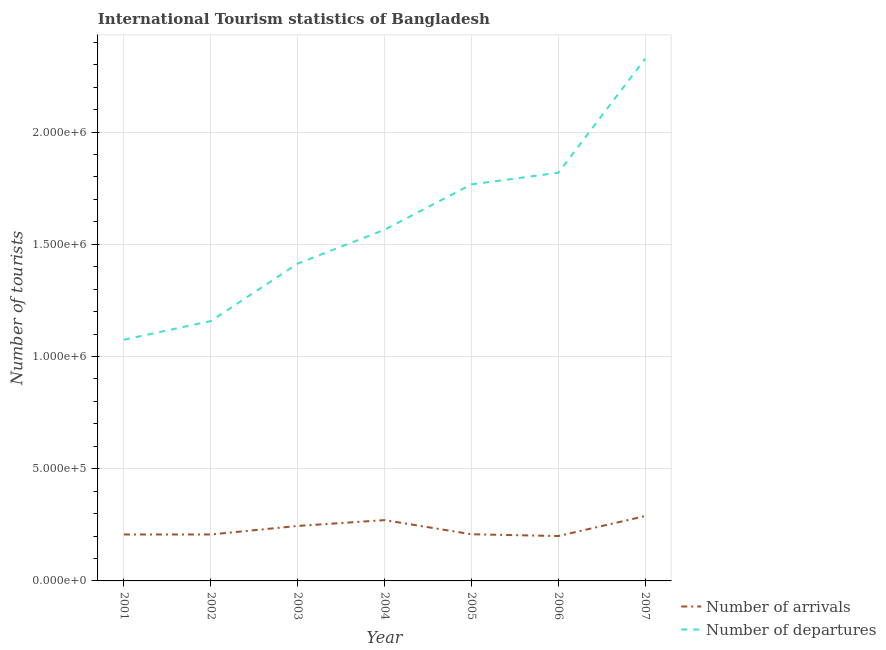Does the line corresponding to number of tourist departures intersect with the line corresponding to number of tourist arrivals?
Offer a terse response. No. What is the number of tourist arrivals in 2004?
Offer a terse response. 2.71e+05. Across all years, what is the maximum number of tourist departures?
Provide a short and direct response. 2.33e+06. Across all years, what is the minimum number of tourist arrivals?
Ensure brevity in your answer.  2.00e+05. In which year was the number of tourist departures maximum?
Your answer should be very brief. 2007. What is the total number of tourist arrivals in the graph?
Offer a very short reply. 1.63e+06. What is the difference between the number of tourist departures in 2001 and that in 2007?
Ensure brevity in your answer.  -1.25e+06. What is the difference between the number of tourist departures in 2004 and the number of tourist arrivals in 2001?
Offer a very short reply. 1.36e+06. What is the average number of tourist arrivals per year?
Offer a very short reply. 2.32e+05. In the year 2002, what is the difference between the number of tourist departures and number of tourist arrivals?
Ensure brevity in your answer.  9.51e+05. What is the ratio of the number of tourist departures in 2003 to that in 2004?
Your response must be concise. 0.9. Is the number of tourist arrivals in 2001 less than that in 2005?
Keep it short and to the point. Yes. Is the difference between the number of tourist arrivals in 2003 and 2005 greater than the difference between the number of tourist departures in 2003 and 2005?
Your answer should be very brief. Yes. What is the difference between the highest and the second highest number of tourist departures?
Give a very brief answer. 5.08e+05. What is the difference between the highest and the lowest number of tourist departures?
Your answer should be very brief. 1.25e+06. Is the number of tourist arrivals strictly greater than the number of tourist departures over the years?
Your answer should be very brief. No. What is the difference between two consecutive major ticks on the Y-axis?
Keep it short and to the point. 5.00e+05. Are the values on the major ticks of Y-axis written in scientific E-notation?
Your answer should be compact. Yes. Does the graph contain any zero values?
Offer a terse response. No. How many legend labels are there?
Keep it short and to the point. 2. What is the title of the graph?
Offer a terse response. International Tourism statistics of Bangladesh. What is the label or title of the Y-axis?
Your response must be concise. Number of tourists. What is the Number of tourists of Number of arrivals in 2001?
Ensure brevity in your answer.  2.07e+05. What is the Number of tourists in Number of departures in 2001?
Provide a short and direct response. 1.08e+06. What is the Number of tourists in Number of arrivals in 2002?
Keep it short and to the point. 2.07e+05. What is the Number of tourists of Number of departures in 2002?
Provide a succinct answer. 1.16e+06. What is the Number of tourists of Number of arrivals in 2003?
Provide a succinct answer. 2.45e+05. What is the Number of tourists of Number of departures in 2003?
Offer a very short reply. 1.41e+06. What is the Number of tourists in Number of arrivals in 2004?
Make the answer very short. 2.71e+05. What is the Number of tourists of Number of departures in 2004?
Your response must be concise. 1.56e+06. What is the Number of tourists in Number of arrivals in 2005?
Make the answer very short. 2.08e+05. What is the Number of tourists in Number of departures in 2005?
Provide a succinct answer. 1.77e+06. What is the Number of tourists in Number of departures in 2006?
Offer a very short reply. 1.82e+06. What is the Number of tourists of Number of arrivals in 2007?
Ensure brevity in your answer.  2.89e+05. What is the Number of tourists in Number of departures in 2007?
Your answer should be very brief. 2.33e+06. Across all years, what is the maximum Number of tourists of Number of arrivals?
Ensure brevity in your answer.  2.89e+05. Across all years, what is the maximum Number of tourists of Number of departures?
Keep it short and to the point. 2.33e+06. Across all years, what is the minimum Number of tourists of Number of departures?
Your response must be concise. 1.08e+06. What is the total Number of tourists of Number of arrivals in the graph?
Your answer should be very brief. 1.63e+06. What is the total Number of tourists in Number of departures in the graph?
Offer a terse response. 1.11e+07. What is the difference between the Number of tourists in Number of arrivals in 2001 and that in 2002?
Give a very brief answer. 0. What is the difference between the Number of tourists of Number of departures in 2001 and that in 2002?
Give a very brief answer. -8.30e+04. What is the difference between the Number of tourists in Number of arrivals in 2001 and that in 2003?
Provide a short and direct response. -3.80e+04. What is the difference between the Number of tourists of Number of departures in 2001 and that in 2003?
Provide a succinct answer. -3.39e+05. What is the difference between the Number of tourists of Number of arrivals in 2001 and that in 2004?
Your response must be concise. -6.40e+04. What is the difference between the Number of tourists of Number of departures in 2001 and that in 2004?
Keep it short and to the point. -4.90e+05. What is the difference between the Number of tourists in Number of arrivals in 2001 and that in 2005?
Make the answer very short. -1000. What is the difference between the Number of tourists in Number of departures in 2001 and that in 2005?
Offer a very short reply. -6.92e+05. What is the difference between the Number of tourists of Number of arrivals in 2001 and that in 2006?
Make the answer very short. 7000. What is the difference between the Number of tourists of Number of departures in 2001 and that in 2006?
Provide a succinct answer. -7.44e+05. What is the difference between the Number of tourists of Number of arrivals in 2001 and that in 2007?
Provide a succinct answer. -8.20e+04. What is the difference between the Number of tourists in Number of departures in 2001 and that in 2007?
Make the answer very short. -1.25e+06. What is the difference between the Number of tourists of Number of arrivals in 2002 and that in 2003?
Keep it short and to the point. -3.80e+04. What is the difference between the Number of tourists of Number of departures in 2002 and that in 2003?
Provide a succinct answer. -2.56e+05. What is the difference between the Number of tourists of Number of arrivals in 2002 and that in 2004?
Provide a short and direct response. -6.40e+04. What is the difference between the Number of tourists in Number of departures in 2002 and that in 2004?
Offer a very short reply. -4.07e+05. What is the difference between the Number of tourists of Number of arrivals in 2002 and that in 2005?
Provide a succinct answer. -1000. What is the difference between the Number of tourists of Number of departures in 2002 and that in 2005?
Your response must be concise. -6.09e+05. What is the difference between the Number of tourists of Number of arrivals in 2002 and that in 2006?
Your answer should be very brief. 7000. What is the difference between the Number of tourists of Number of departures in 2002 and that in 2006?
Offer a very short reply. -6.61e+05. What is the difference between the Number of tourists in Number of arrivals in 2002 and that in 2007?
Your response must be concise. -8.20e+04. What is the difference between the Number of tourists in Number of departures in 2002 and that in 2007?
Keep it short and to the point. -1.17e+06. What is the difference between the Number of tourists in Number of arrivals in 2003 and that in 2004?
Your answer should be compact. -2.60e+04. What is the difference between the Number of tourists in Number of departures in 2003 and that in 2004?
Provide a short and direct response. -1.51e+05. What is the difference between the Number of tourists of Number of arrivals in 2003 and that in 2005?
Offer a terse response. 3.70e+04. What is the difference between the Number of tourists in Number of departures in 2003 and that in 2005?
Provide a short and direct response. -3.53e+05. What is the difference between the Number of tourists of Number of arrivals in 2003 and that in 2006?
Keep it short and to the point. 4.50e+04. What is the difference between the Number of tourists in Number of departures in 2003 and that in 2006?
Your answer should be compact. -4.05e+05. What is the difference between the Number of tourists in Number of arrivals in 2003 and that in 2007?
Keep it short and to the point. -4.40e+04. What is the difference between the Number of tourists in Number of departures in 2003 and that in 2007?
Offer a terse response. -9.13e+05. What is the difference between the Number of tourists in Number of arrivals in 2004 and that in 2005?
Your response must be concise. 6.30e+04. What is the difference between the Number of tourists in Number of departures in 2004 and that in 2005?
Provide a succinct answer. -2.02e+05. What is the difference between the Number of tourists in Number of arrivals in 2004 and that in 2006?
Offer a terse response. 7.10e+04. What is the difference between the Number of tourists of Number of departures in 2004 and that in 2006?
Ensure brevity in your answer.  -2.54e+05. What is the difference between the Number of tourists in Number of arrivals in 2004 and that in 2007?
Offer a terse response. -1.80e+04. What is the difference between the Number of tourists in Number of departures in 2004 and that in 2007?
Provide a succinct answer. -7.62e+05. What is the difference between the Number of tourists of Number of arrivals in 2005 and that in 2006?
Ensure brevity in your answer.  8000. What is the difference between the Number of tourists in Number of departures in 2005 and that in 2006?
Offer a very short reply. -5.20e+04. What is the difference between the Number of tourists in Number of arrivals in 2005 and that in 2007?
Your response must be concise. -8.10e+04. What is the difference between the Number of tourists in Number of departures in 2005 and that in 2007?
Make the answer very short. -5.60e+05. What is the difference between the Number of tourists of Number of arrivals in 2006 and that in 2007?
Provide a succinct answer. -8.90e+04. What is the difference between the Number of tourists in Number of departures in 2006 and that in 2007?
Keep it short and to the point. -5.08e+05. What is the difference between the Number of tourists of Number of arrivals in 2001 and the Number of tourists of Number of departures in 2002?
Give a very brief answer. -9.51e+05. What is the difference between the Number of tourists of Number of arrivals in 2001 and the Number of tourists of Number of departures in 2003?
Make the answer very short. -1.21e+06. What is the difference between the Number of tourists in Number of arrivals in 2001 and the Number of tourists in Number of departures in 2004?
Your answer should be very brief. -1.36e+06. What is the difference between the Number of tourists of Number of arrivals in 2001 and the Number of tourists of Number of departures in 2005?
Your response must be concise. -1.56e+06. What is the difference between the Number of tourists of Number of arrivals in 2001 and the Number of tourists of Number of departures in 2006?
Ensure brevity in your answer.  -1.61e+06. What is the difference between the Number of tourists in Number of arrivals in 2001 and the Number of tourists in Number of departures in 2007?
Your response must be concise. -2.12e+06. What is the difference between the Number of tourists in Number of arrivals in 2002 and the Number of tourists in Number of departures in 2003?
Offer a very short reply. -1.21e+06. What is the difference between the Number of tourists of Number of arrivals in 2002 and the Number of tourists of Number of departures in 2004?
Make the answer very short. -1.36e+06. What is the difference between the Number of tourists in Number of arrivals in 2002 and the Number of tourists in Number of departures in 2005?
Provide a short and direct response. -1.56e+06. What is the difference between the Number of tourists in Number of arrivals in 2002 and the Number of tourists in Number of departures in 2006?
Your response must be concise. -1.61e+06. What is the difference between the Number of tourists in Number of arrivals in 2002 and the Number of tourists in Number of departures in 2007?
Give a very brief answer. -2.12e+06. What is the difference between the Number of tourists of Number of arrivals in 2003 and the Number of tourists of Number of departures in 2004?
Provide a succinct answer. -1.32e+06. What is the difference between the Number of tourists in Number of arrivals in 2003 and the Number of tourists in Number of departures in 2005?
Keep it short and to the point. -1.52e+06. What is the difference between the Number of tourists of Number of arrivals in 2003 and the Number of tourists of Number of departures in 2006?
Offer a very short reply. -1.57e+06. What is the difference between the Number of tourists in Number of arrivals in 2003 and the Number of tourists in Number of departures in 2007?
Ensure brevity in your answer.  -2.08e+06. What is the difference between the Number of tourists of Number of arrivals in 2004 and the Number of tourists of Number of departures in 2005?
Keep it short and to the point. -1.50e+06. What is the difference between the Number of tourists in Number of arrivals in 2004 and the Number of tourists in Number of departures in 2006?
Your response must be concise. -1.55e+06. What is the difference between the Number of tourists of Number of arrivals in 2004 and the Number of tourists of Number of departures in 2007?
Your answer should be very brief. -2.06e+06. What is the difference between the Number of tourists of Number of arrivals in 2005 and the Number of tourists of Number of departures in 2006?
Provide a succinct answer. -1.61e+06. What is the difference between the Number of tourists of Number of arrivals in 2005 and the Number of tourists of Number of departures in 2007?
Make the answer very short. -2.12e+06. What is the difference between the Number of tourists in Number of arrivals in 2006 and the Number of tourists in Number of departures in 2007?
Offer a terse response. -2.13e+06. What is the average Number of tourists in Number of arrivals per year?
Offer a very short reply. 2.32e+05. What is the average Number of tourists of Number of departures per year?
Your answer should be compact. 1.59e+06. In the year 2001, what is the difference between the Number of tourists in Number of arrivals and Number of tourists in Number of departures?
Ensure brevity in your answer.  -8.68e+05. In the year 2002, what is the difference between the Number of tourists in Number of arrivals and Number of tourists in Number of departures?
Keep it short and to the point. -9.51e+05. In the year 2003, what is the difference between the Number of tourists of Number of arrivals and Number of tourists of Number of departures?
Make the answer very short. -1.17e+06. In the year 2004, what is the difference between the Number of tourists in Number of arrivals and Number of tourists in Number of departures?
Provide a short and direct response. -1.29e+06. In the year 2005, what is the difference between the Number of tourists in Number of arrivals and Number of tourists in Number of departures?
Offer a terse response. -1.56e+06. In the year 2006, what is the difference between the Number of tourists of Number of arrivals and Number of tourists of Number of departures?
Offer a terse response. -1.62e+06. In the year 2007, what is the difference between the Number of tourists of Number of arrivals and Number of tourists of Number of departures?
Your response must be concise. -2.04e+06. What is the ratio of the Number of tourists in Number of arrivals in 2001 to that in 2002?
Give a very brief answer. 1. What is the ratio of the Number of tourists in Number of departures in 2001 to that in 2002?
Your answer should be very brief. 0.93. What is the ratio of the Number of tourists of Number of arrivals in 2001 to that in 2003?
Your answer should be compact. 0.84. What is the ratio of the Number of tourists of Number of departures in 2001 to that in 2003?
Keep it short and to the point. 0.76. What is the ratio of the Number of tourists in Number of arrivals in 2001 to that in 2004?
Your answer should be very brief. 0.76. What is the ratio of the Number of tourists in Number of departures in 2001 to that in 2004?
Keep it short and to the point. 0.69. What is the ratio of the Number of tourists in Number of departures in 2001 to that in 2005?
Keep it short and to the point. 0.61. What is the ratio of the Number of tourists of Number of arrivals in 2001 to that in 2006?
Your answer should be compact. 1.03. What is the ratio of the Number of tourists of Number of departures in 2001 to that in 2006?
Make the answer very short. 0.59. What is the ratio of the Number of tourists in Number of arrivals in 2001 to that in 2007?
Make the answer very short. 0.72. What is the ratio of the Number of tourists of Number of departures in 2001 to that in 2007?
Offer a terse response. 0.46. What is the ratio of the Number of tourists in Number of arrivals in 2002 to that in 2003?
Provide a succinct answer. 0.84. What is the ratio of the Number of tourists in Number of departures in 2002 to that in 2003?
Your answer should be very brief. 0.82. What is the ratio of the Number of tourists of Number of arrivals in 2002 to that in 2004?
Give a very brief answer. 0.76. What is the ratio of the Number of tourists of Number of departures in 2002 to that in 2004?
Your response must be concise. 0.74. What is the ratio of the Number of tourists in Number of arrivals in 2002 to that in 2005?
Provide a short and direct response. 1. What is the ratio of the Number of tourists in Number of departures in 2002 to that in 2005?
Give a very brief answer. 0.66. What is the ratio of the Number of tourists of Number of arrivals in 2002 to that in 2006?
Ensure brevity in your answer.  1.03. What is the ratio of the Number of tourists of Number of departures in 2002 to that in 2006?
Your answer should be very brief. 0.64. What is the ratio of the Number of tourists of Number of arrivals in 2002 to that in 2007?
Ensure brevity in your answer.  0.72. What is the ratio of the Number of tourists in Number of departures in 2002 to that in 2007?
Keep it short and to the point. 0.5. What is the ratio of the Number of tourists of Number of arrivals in 2003 to that in 2004?
Give a very brief answer. 0.9. What is the ratio of the Number of tourists in Number of departures in 2003 to that in 2004?
Your answer should be compact. 0.9. What is the ratio of the Number of tourists of Number of arrivals in 2003 to that in 2005?
Keep it short and to the point. 1.18. What is the ratio of the Number of tourists in Number of departures in 2003 to that in 2005?
Keep it short and to the point. 0.8. What is the ratio of the Number of tourists of Number of arrivals in 2003 to that in 2006?
Offer a very short reply. 1.23. What is the ratio of the Number of tourists of Number of departures in 2003 to that in 2006?
Your response must be concise. 0.78. What is the ratio of the Number of tourists in Number of arrivals in 2003 to that in 2007?
Ensure brevity in your answer.  0.85. What is the ratio of the Number of tourists of Number of departures in 2003 to that in 2007?
Offer a terse response. 0.61. What is the ratio of the Number of tourists in Number of arrivals in 2004 to that in 2005?
Provide a succinct answer. 1.3. What is the ratio of the Number of tourists in Number of departures in 2004 to that in 2005?
Your answer should be compact. 0.89. What is the ratio of the Number of tourists of Number of arrivals in 2004 to that in 2006?
Offer a terse response. 1.35. What is the ratio of the Number of tourists of Number of departures in 2004 to that in 2006?
Offer a terse response. 0.86. What is the ratio of the Number of tourists in Number of arrivals in 2004 to that in 2007?
Provide a succinct answer. 0.94. What is the ratio of the Number of tourists in Number of departures in 2004 to that in 2007?
Your answer should be very brief. 0.67. What is the ratio of the Number of tourists of Number of departures in 2005 to that in 2006?
Give a very brief answer. 0.97. What is the ratio of the Number of tourists of Number of arrivals in 2005 to that in 2007?
Offer a very short reply. 0.72. What is the ratio of the Number of tourists of Number of departures in 2005 to that in 2007?
Your answer should be compact. 0.76. What is the ratio of the Number of tourists in Number of arrivals in 2006 to that in 2007?
Keep it short and to the point. 0.69. What is the ratio of the Number of tourists in Number of departures in 2006 to that in 2007?
Keep it short and to the point. 0.78. What is the difference between the highest and the second highest Number of tourists of Number of arrivals?
Your response must be concise. 1.80e+04. What is the difference between the highest and the second highest Number of tourists of Number of departures?
Provide a succinct answer. 5.08e+05. What is the difference between the highest and the lowest Number of tourists of Number of arrivals?
Your answer should be very brief. 8.90e+04. What is the difference between the highest and the lowest Number of tourists in Number of departures?
Your answer should be very brief. 1.25e+06. 